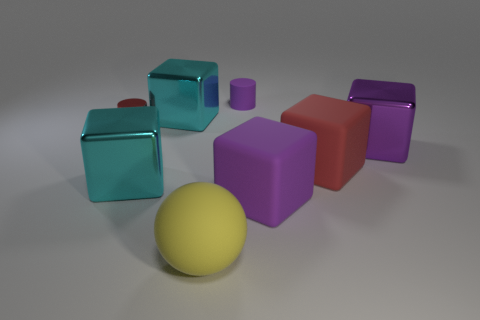Subtract all rubber blocks. How many blocks are left? 3 Subtract all red blocks. How many blocks are left? 4 Add 1 matte blocks. How many objects exist? 9 Subtract all brown blocks. Subtract all brown cylinders. How many blocks are left? 5 Subtract all cubes. How many objects are left? 3 Subtract 1 red blocks. How many objects are left? 7 Subtract all cyan blocks. Subtract all rubber balls. How many objects are left? 5 Add 5 big metal cubes. How many big metal cubes are left? 8 Add 3 large yellow rubber objects. How many large yellow rubber objects exist? 4 